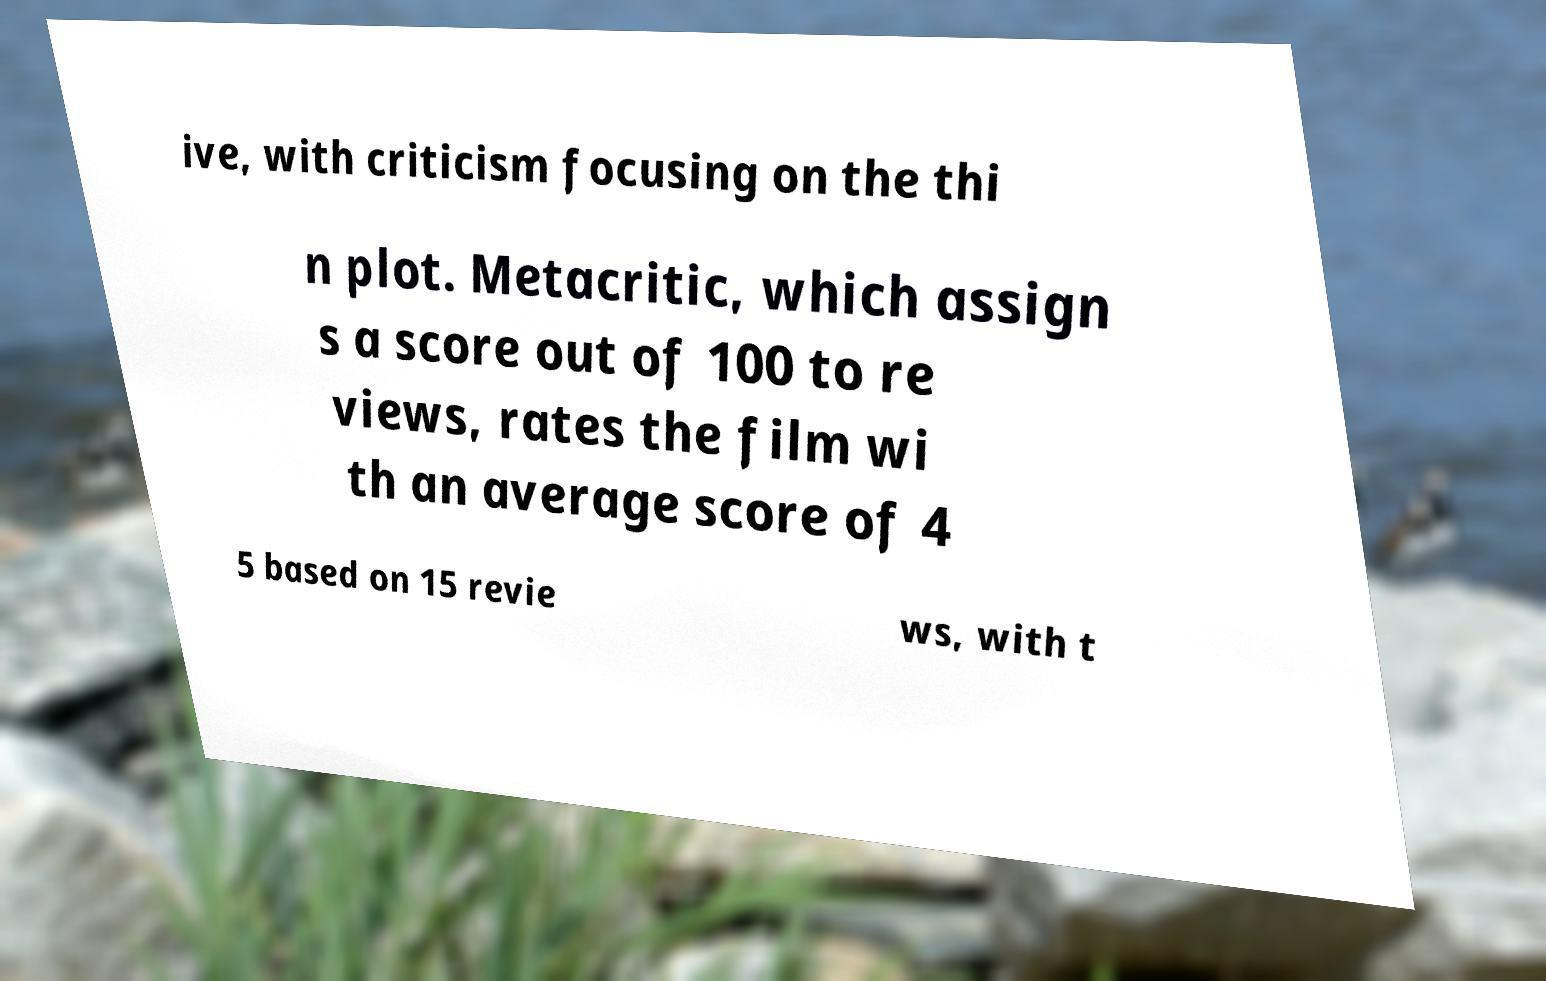For documentation purposes, I need the text within this image transcribed. Could you provide that? ive, with criticism focusing on the thi n plot. Metacritic, which assign s a score out of 100 to re views, rates the film wi th an average score of 4 5 based on 15 revie ws, with t 